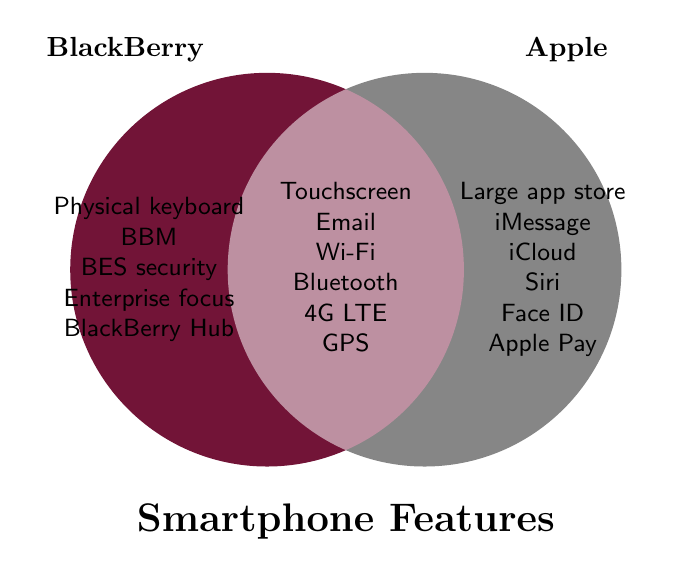What are two features that both BlackBerry and Apple smartphones share? Both devices share common features listed in the overlapping section of the Venn Diagram. For this question, we look at individual items in the shared section and identify two: Touchscreen and Email.
Answer: Touchscreen, Email How many features are unique to Apple smartphones? Count the items in the section labeled for Apple smartphones. These are: Large app store, iMessage, iCloud, Siri, Face ID, and Apple Pay, totaling six features.
Answer: Six What is a unique feature of BlackBerry smartphones related to messaging? Look at the section labeled for BlackBerry and identify any features related to messaging. BBM is unique to BlackBerry and is related to messaging.
Answer: BBM Which company has a focus on enterprise security according to the diagram? Find the features listed under BlackBerry and Apple. "BES security" and "Enterprise focus" are listed under BlackBerry, indicating it has a business orientation.
Answer: BlackBerry What feature is common that enhances wireless connectivity for both BlackBerry and Apple? Find a shared feature related to wireless connectivity in the overlapping section of the Venn Diagram. Wi-Fi is listed and enhances wireless connectivity for both.
Answer: Wi-Fi How many common features are listed between BlackBerry and Apple smartphones? Count all the items listed in the overlapping (middle) section of the Venn Diagram that they share: Touchscreen, Email, Wi-Fi, Bluetooth, 4G LTE, and GPS, totaling six features.
Answer: Six Identify a security feature unique to Apple smartphones. Look at the section labeled for Apple and identify any features related to security. Face ID appears as a unique security feature for Apple smartphones.
Answer: Face ID What shared feature is essential for internet usage in both types of smartphones? Look at the overlapping section to identify shared features necessary for internet use. Web browsing is essential for internet usage.
Answer: Web browsing Which smartphone brand promotes more app functionality and variety? Compare the app-related features in both sections. BlackBerry has "Limited apps," while Apple has "Large app store" and "App Store." This indicates Apple promotes more variety and functionality.
Answer: Apple What is a typical input method unique to BlackBerry smartphones? Find a feature in the BlackBerry section related to input methods. The Physical keyboard and Trackpad are specific input methods for BlackBerry.
Answer: Physical keyboard 